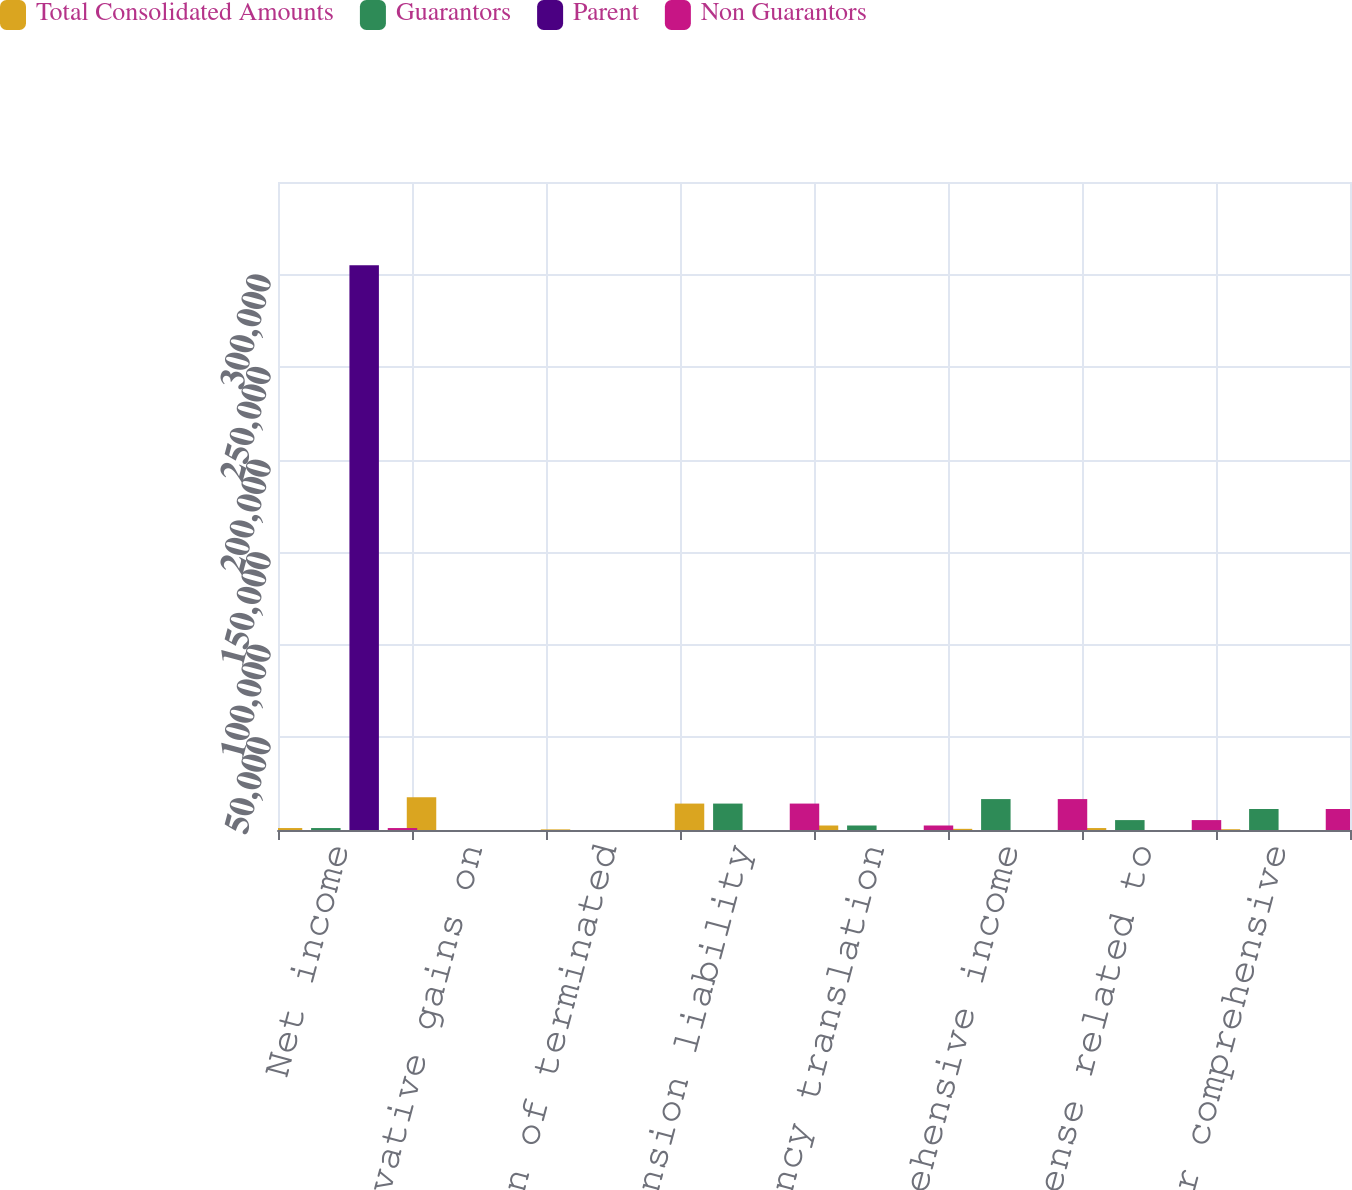<chart> <loc_0><loc_0><loc_500><loc_500><stacked_bar_chart><ecel><fcel>Net income<fcel>Unrealized derivative gains on<fcel>Amortization of terminated<fcel>Minimum pension liability<fcel>Foreign currency translation<fcel>Other comprehensive income<fcel>Income tax expense related to<fcel>Total other comprehensive<nl><fcel>Total Consolidated Amounts<fcel>1053<fcel>17668<fcel>336<fcel>14270<fcel>2431<fcel>631<fcel>1053<fcel>422<nl><fcel>Guarantors<fcel>1053<fcel>0<fcel>0<fcel>14270<fcel>2431<fcel>16701<fcel>5356<fcel>11345<nl><fcel>Parent<fcel>304995<fcel>0<fcel>0<fcel>0<fcel>0<fcel>0<fcel>0<fcel>0<nl><fcel>Non Guarantors<fcel>1053<fcel>0<fcel>0<fcel>14270<fcel>2431<fcel>16701<fcel>5356<fcel>11345<nl></chart> 